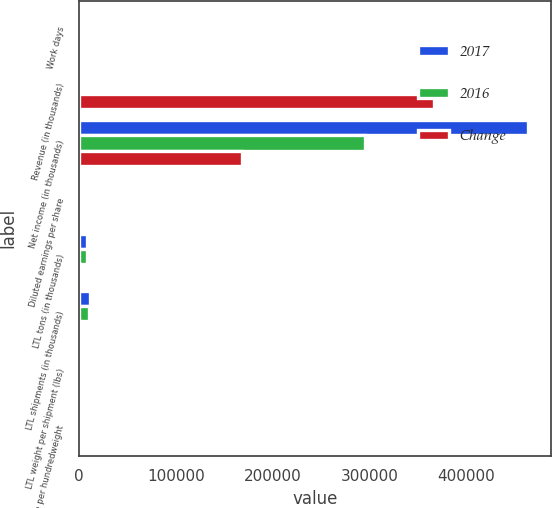Convert chart to OTSL. <chart><loc_0><loc_0><loc_500><loc_500><stacked_bar_chart><ecel><fcel>Work days<fcel>Revenue (in thousands)<fcel>Net income (in thousands)<fcel>Diluted earnings per share<fcel>LTL tons (in thousands)<fcel>LTL shipments (in thousands)<fcel>LTL weight per shipment (lbs)<fcel>LTL revenue per hundredweight<nl><fcel>2017<fcel>253<fcel>588<fcel>463774<fcel>5.63<fcel>8519<fcel>10736<fcel>1587<fcel>19.39<nl><fcel>2016<fcel>254<fcel>588<fcel>295765<fcel>3.56<fcel>7931<fcel>10148<fcel>1563<fcel>18.51<nl><fcel>Change<fcel>1<fcel>366595<fcel>168009<fcel>2.07<fcel>588<fcel>588<fcel>24<fcel>0.88<nl></chart> 